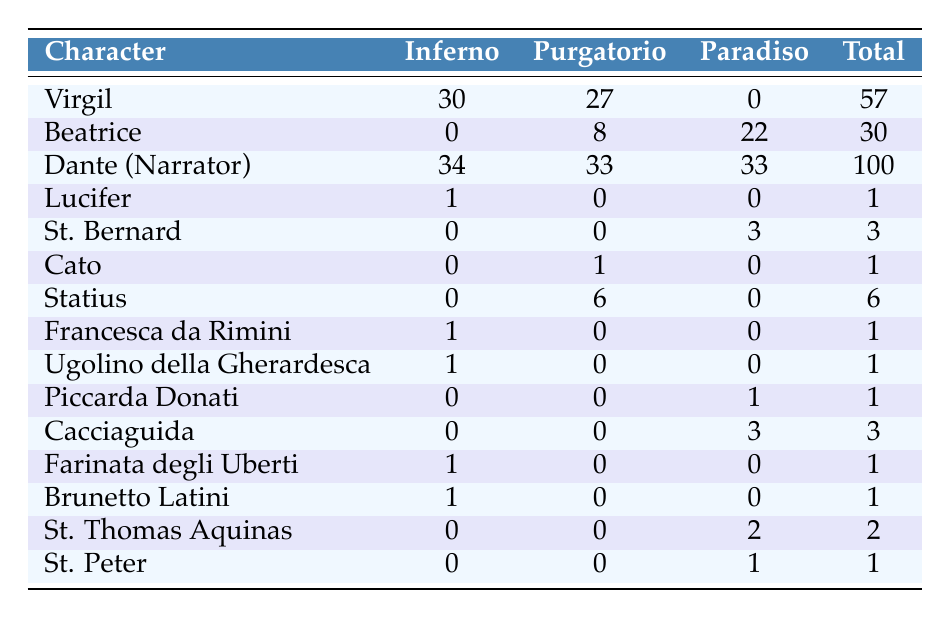What character has the highest total appearances across all three canticles? By looking at the "Total Appearances" column, Dante (Narrator) has the highest count with 100 appearances.
Answer: Dante (Narrator) How many times does Virgil appear in Purgatorio? The table shows that Virgil appears 27 times in Purgatorio, as indicated in the corresponding cell.
Answer: 27 Does Cato appear in Paradiso? The table indicates that Cato has 0 appearances in Paradiso, which means he does not appear in that canticle.
Answer: No What is the total number of appearances for St. Thomas Aquinas across all canticles? To find this, we look at the "Total Appearances" column: St. Thomas Aquinas appears 2 times.
Answer: 2 Which character appears the most in Inferno, and how many times? Checking the "Inferno" column, Virgil appears 30 times, which is the highest compared to other characters in that column.
Answer: Virgil, 30 times What is the difference in total appearances between Dante (Narrator) and Beatrice? Dante (Narrator) has 100 total appearances, while Beatrice has 30. The difference is 100 - 30 = 70.
Answer: 70 Which character has appearances only in Paradiso? Observing the table, Piccarda Donati and Cacciaguida appear only in Paradiso, as their counts in Inferno and Purgatorio are both zero.
Answer: Piccarda Donati and Cacciaguida How many characters appear in both Purgatorio and Paradiso but not in Inferno? By examining the table, only St. Bernard and St. Peter appear in Purgatorio (3 and 1 times, respectively) and Paradiso (3 and 1 times, respectively) while having 0 appearances in Inferno. Thus, there are two characters.
Answer: 2 What is the average number of appearances for characters in Paradiso? To find the average, sum the appearances in Paradiso (0 + 22 + 33 + 0 + 3 + 0 + 0 + 1 + 0 + 3 + 0 + 0 + 2 + 1 = 65) and divide by the number of characters (14). Therefore, the average is 65/14 ≈ 4.64.
Answer: 4.64 Which character appears the least number of times in total? Looking at the "Total Appearances" column, multiple characters appear a total of 1 time; however, Lucifer appears only once overall, making him the least.
Answer: Lucifer 